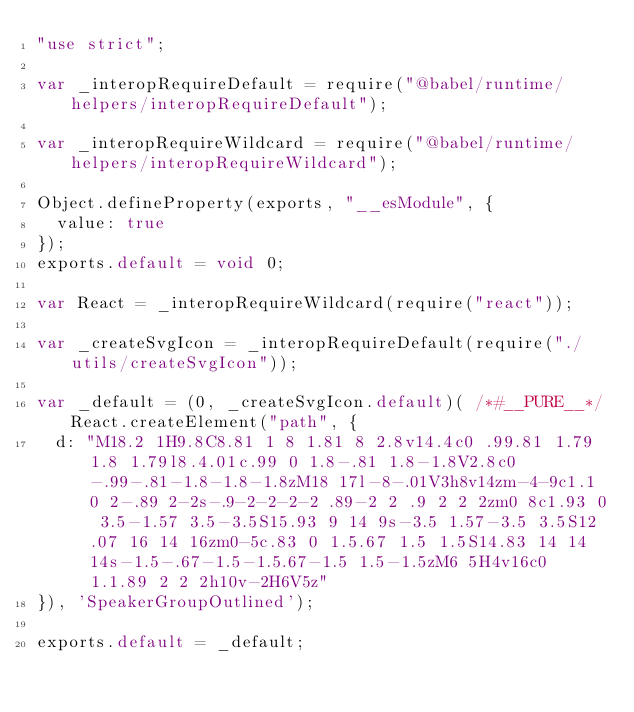<code> <loc_0><loc_0><loc_500><loc_500><_JavaScript_>"use strict";

var _interopRequireDefault = require("@babel/runtime/helpers/interopRequireDefault");

var _interopRequireWildcard = require("@babel/runtime/helpers/interopRequireWildcard");

Object.defineProperty(exports, "__esModule", {
  value: true
});
exports.default = void 0;

var React = _interopRequireWildcard(require("react"));

var _createSvgIcon = _interopRequireDefault(require("./utils/createSvgIcon"));

var _default = (0, _createSvgIcon.default)( /*#__PURE__*/React.createElement("path", {
  d: "M18.2 1H9.8C8.81 1 8 1.81 8 2.8v14.4c0 .99.81 1.79 1.8 1.79l8.4.01c.99 0 1.8-.81 1.8-1.8V2.8c0-.99-.81-1.8-1.8-1.8zM18 17l-8-.01V3h8v14zm-4-9c1.1 0 2-.89 2-2s-.9-2-2-2-2 .89-2 2 .9 2 2 2zm0 8c1.93 0 3.5-1.57 3.5-3.5S15.93 9 14 9s-3.5 1.57-3.5 3.5S12.07 16 14 16zm0-5c.83 0 1.5.67 1.5 1.5S14.83 14 14 14s-1.5-.67-1.5-1.5.67-1.5 1.5-1.5zM6 5H4v16c0 1.1.89 2 2 2h10v-2H6V5z"
}), 'SpeakerGroupOutlined');

exports.default = _default;</code> 